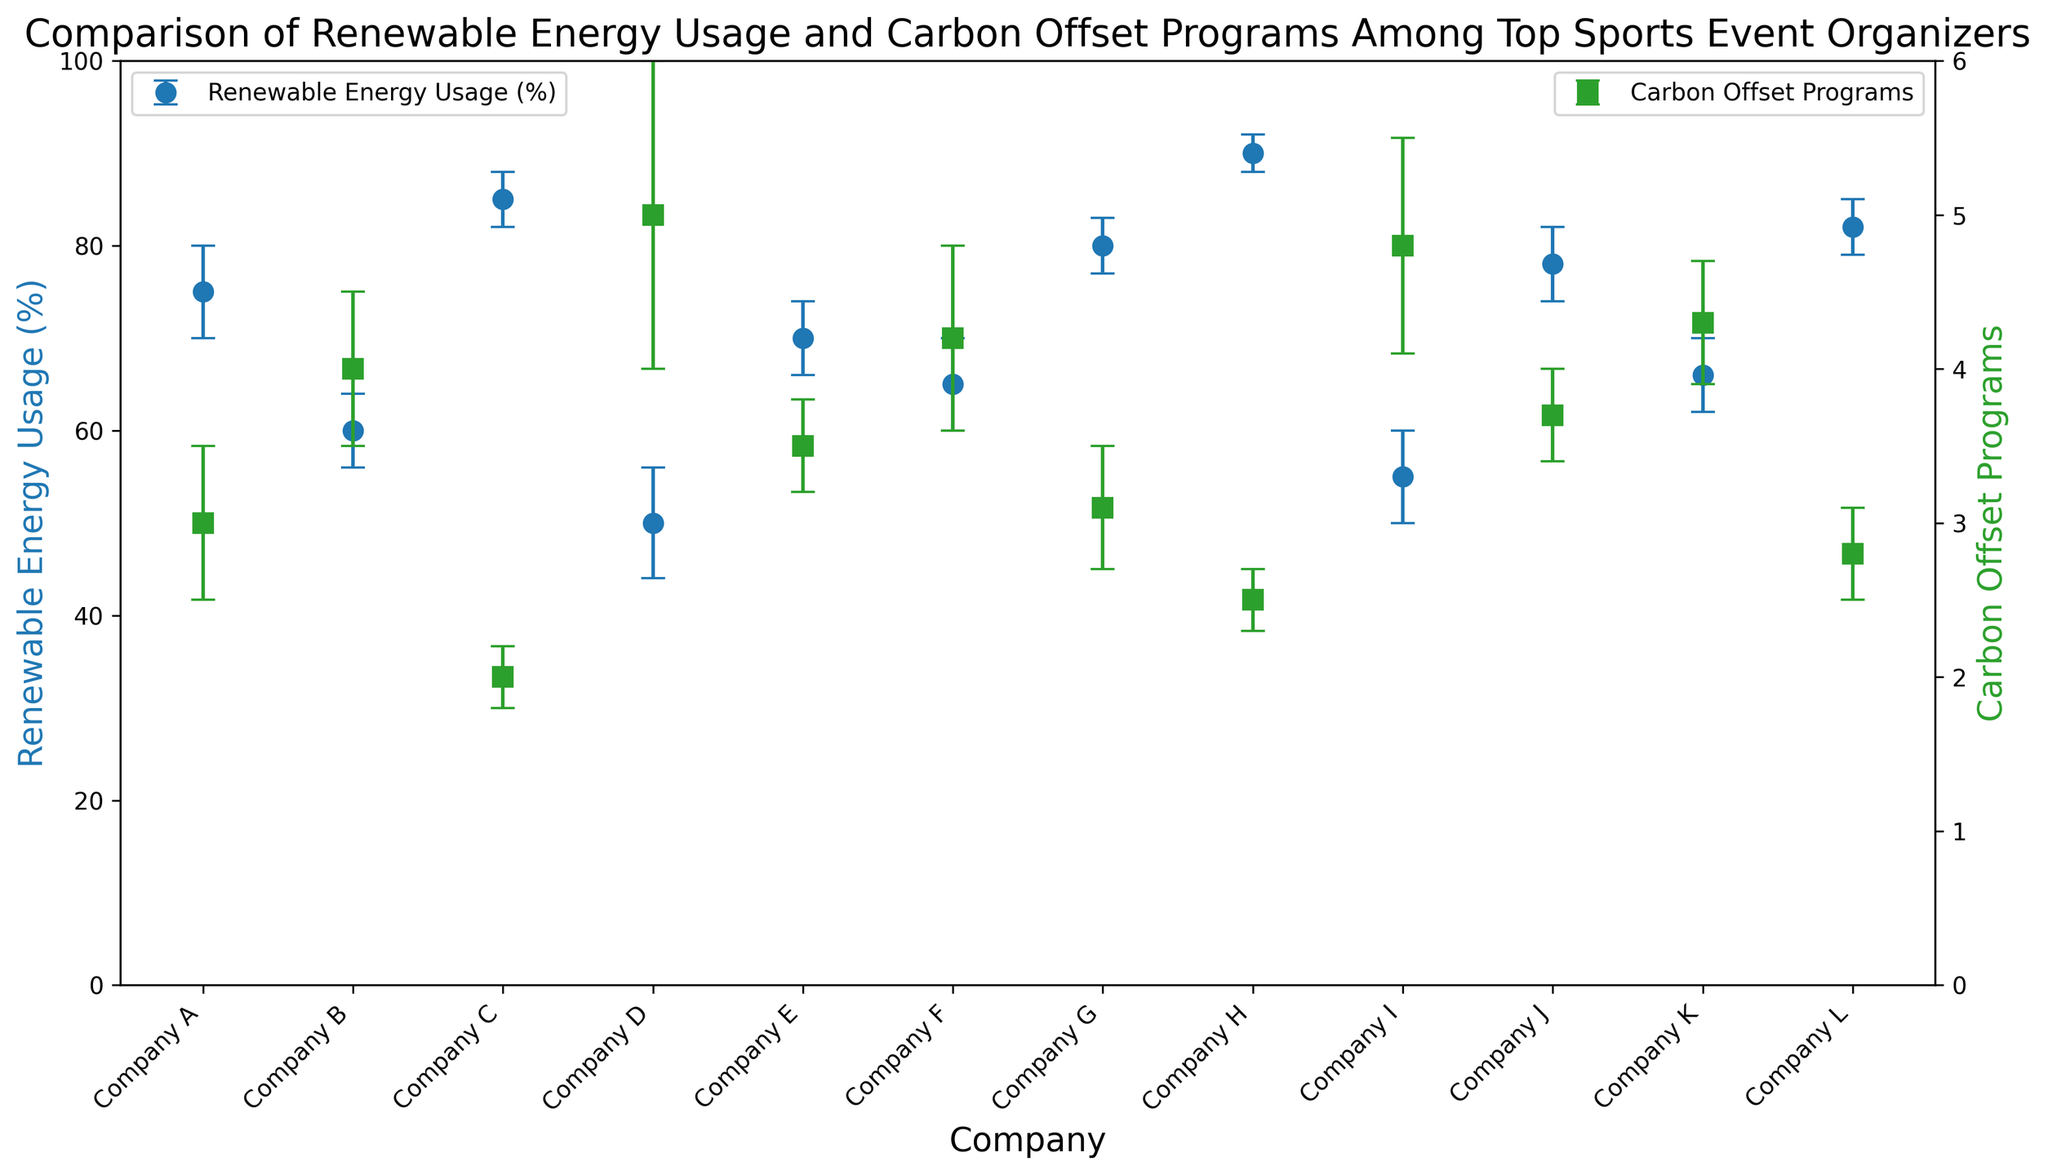Which company has the highest renewable energy usage percentage? Company H has the highest renewable energy usage percentage at 90%, as indicated by the highest point on the graph for renewable energy usage.
Answer: Company H Which company has the lowest number of carbon offset programs? Company C has the lowest number of carbon offset programs at 2, indicated by the lowest point on the graph for carbon offset programs.
Answer: Company C What is the difference in renewable energy usage percentage between Company A and Company D? Company A has 75% and Company D has 50%, so the difference is 75% - 50% = 25%.
Answer: 25% Which company has the smallest error in renewable energy usage? Company H has the smallest error in renewable energy usage at 2%, indicated by the error bar lengths.
Answer: Company H What is the average percentage of renewable energy usage among Company E, Company F, and Company G? The average is calculated as (70 + 65 + 80) / 3 = 215 / 3 ≈ 71.67%.
Answer: 71.67% Which two companies have an equal number of carbon offset programs? Companies B and K each have 4 carbon offset programs, shown by the identical points on the carbon offset programs axis.
Answer: Companies B and K Does Company J have a higher renewable energy usage than Company F? Yes, Company J has 78% renewable energy usage while Company F has 65%, indicated by the relative heights of their points on the graph.
Answer: Yes What is the total number of carbon offset programs for Company I and Company L combined? Company I has 4.8 and Company L has 2.8 carbon offset programs. The total is 4.8 + 2.8 = 7.6.
Answer: 7.6 Which company has the largest error in their carbon offset programs? Company D has the largest error in carbon offset programs at 1, shown by the longest error bar for carbon offset programs.
Answer: Company D How does the renewable energy usage of Company G compare to the renewable energy usage of Company K? Company G has 80% renewable energy usage while Company K has 66%, so Company G has higher renewable energy usage.
Answer: Company G has higher renewable energy usage 